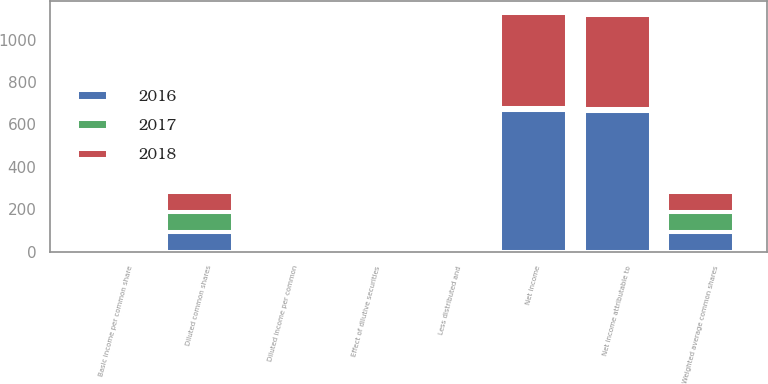Convert chart to OTSL. <chart><loc_0><loc_0><loc_500><loc_500><stacked_bar_chart><ecel><fcel>Net income<fcel>Less distributed and<fcel>Net income attributable to<fcel>Weighted average common shares<fcel>Effect of dilutive securities<fcel>Diluted common shares<fcel>Basic income per common share<fcel>Diluted income per common<nl><fcel>2017<fcel>7.81<fcel>5.7<fcel>7.81<fcel>93.7<fcel>0.2<fcel>93.9<fcel>7.82<fcel>7.8<nl><fcel>2016<fcel>668.6<fcel>5.6<fcel>663<fcel>93.5<fcel>0.2<fcel>93.7<fcel>7.09<fcel>7.07<nl><fcel>2018<fcel>449.6<fcel>4.4<fcel>445.2<fcel>93.5<fcel>0.2<fcel>93.7<fcel>4.76<fcel>4.75<nl></chart> 